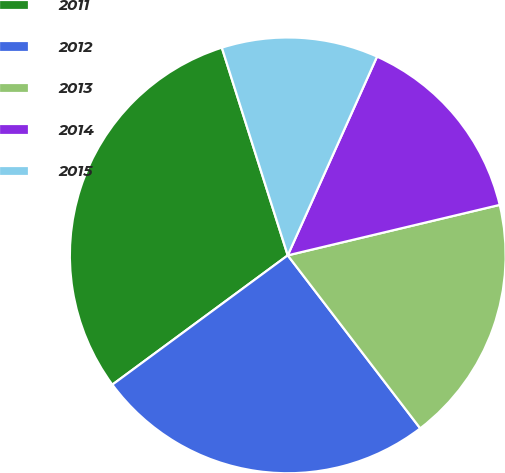Convert chart to OTSL. <chart><loc_0><loc_0><loc_500><loc_500><pie_chart><fcel>2011<fcel>2012<fcel>2013<fcel>2014<fcel>2015<nl><fcel>30.22%<fcel>25.29%<fcel>18.32%<fcel>14.56%<fcel>11.61%<nl></chart> 